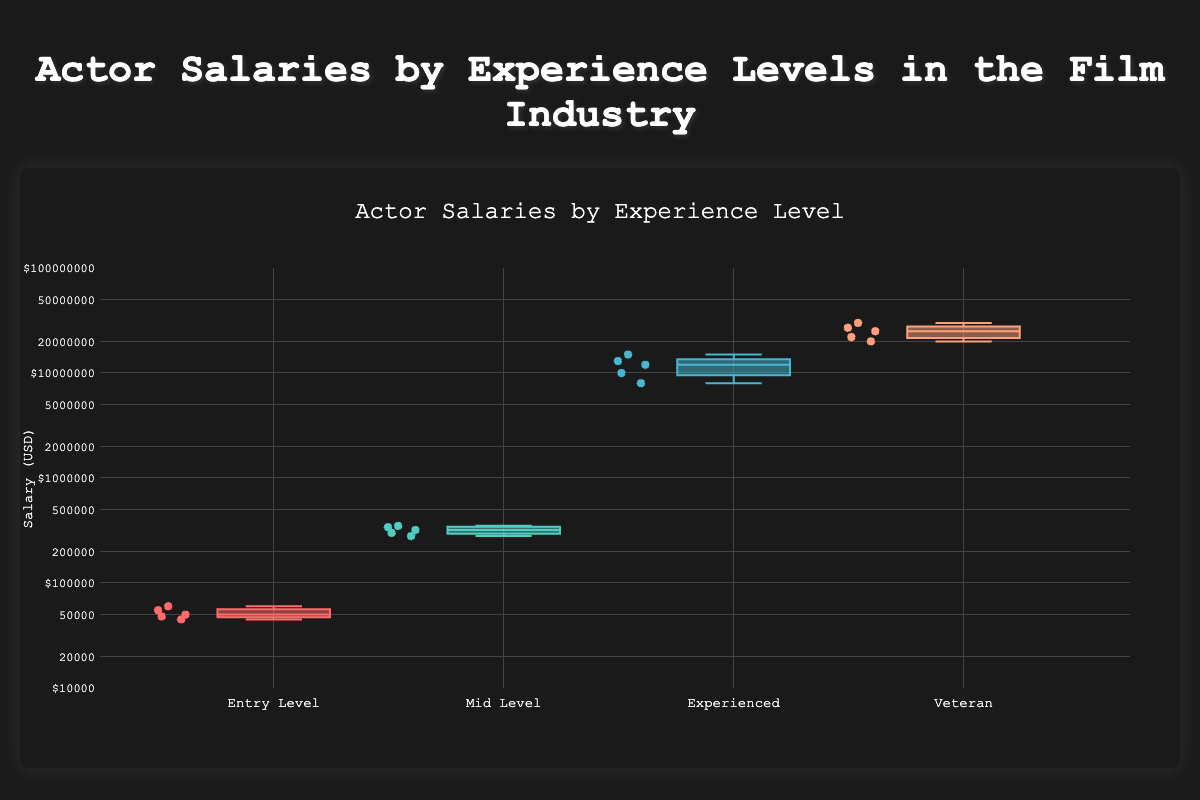How many experience levels are represented in the box plot? The box plot shows four different experience levels, each labeled on the x-axis.
Answer: Four Which experience level shows the highest median salary? The experience level with the highest median salary can be identified by looking at the central line inside the box. For the 'Veteran' category, this line is closest to the top of its box, hence the highest median salary.
Answer: Veteran Which experience level has the widest range of salaries? The range of salaries is indicated by the distance between the lowest (bottom whisker) and highest (top whisker) points in each box. The 'Veteran' category shows the widest range due to the large distance between its minimum and maximum salaries.
Answer: Veteran What is the median salary for the "Experienced" level? To determine the median, locate the line inside the box for the "Experienced" level, which on closer inspection implies a median salary in the middle of its range.
Answer: Approximately $13,000,000 Which experience level has the smallest interquartile range (IQR)? The IQR is the distance between the top of the lower quartile (bottom of the box) and the bottom of the upper quartile (top of the box). The "Entry Level" has the smallest IQR as its box is the smallest in height.
Answer: Entry Level Compare the highest salaries between the "Mid-Level" and "Experienced" categories. To compare these salaries, look at the top whiskers of each category. The "Experienced" category has a higher top whisker, indicating a higher maximum salary than the "Mid-Level" category.
Answer: Experienced What is the lowest salary recorded for "Entry Level" actors? The lowest salary can be identified by looking at the bottom whisker for the "Entry Level" category. The lowest point on this whisker corresponds to $45,000.
Answer: $45,000 Calculate the average salary of the actors in the "Veteran" category. Sum the salaries of the actors in the "Veteran" category: 25M + 30M + 27M + 20M + 22M = 124M, and divide by 5 actors, resulting in 124M / 5.
Answer: $24,800,000 